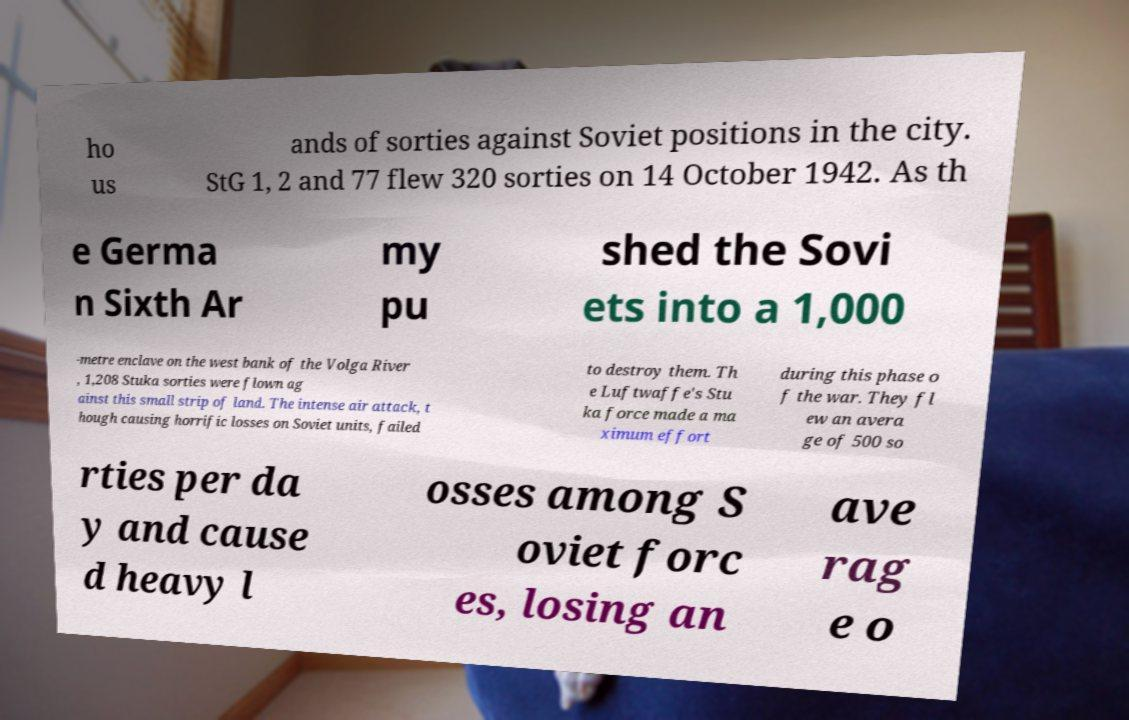For documentation purposes, I need the text within this image transcribed. Could you provide that? ho us ands of sorties against Soviet positions in the city. StG 1, 2 and 77 flew 320 sorties on 14 October 1942. As th e Germa n Sixth Ar my pu shed the Sovi ets into a 1,000 -metre enclave on the west bank of the Volga River , 1,208 Stuka sorties were flown ag ainst this small strip of land. The intense air attack, t hough causing horrific losses on Soviet units, failed to destroy them. Th e Luftwaffe's Stu ka force made a ma ximum effort during this phase o f the war. They fl ew an avera ge of 500 so rties per da y and cause d heavy l osses among S oviet forc es, losing an ave rag e o 